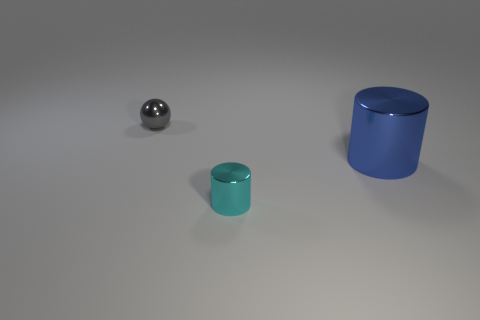Can you describe the lighting in the scene? The lighting in the scene appears to be diffuse overhead lighting, creating soft shadows beneath the objects. 